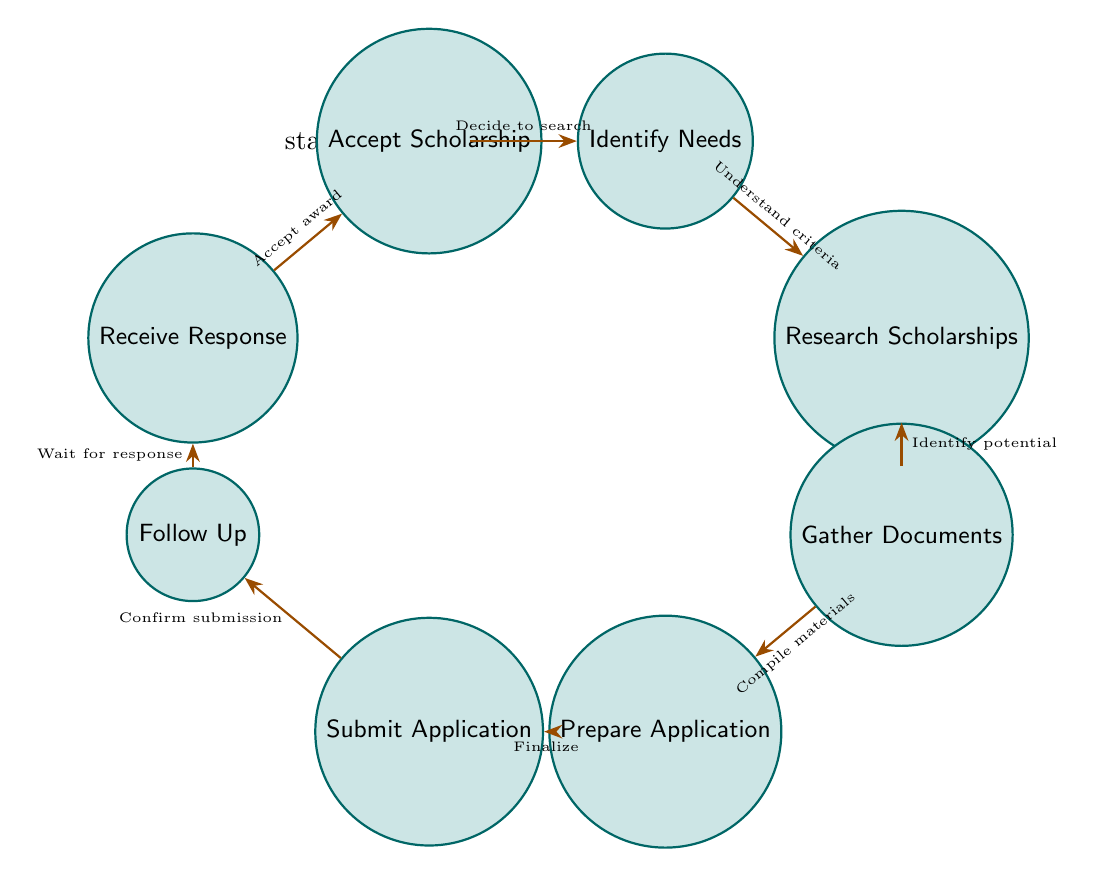What is the initial state of the diagram? The diagram begins at the "Start" state, which is indicated as the initial state.
Answer: Start How many states are there in total? By counting each unique state as represented in the diagram, there are a total of 9 states.
Answer: 9 What is the last state in the process? The last state, as indicated in the flow of the diagram, is "Accept Scholarship."
Answer: Accept Scholarship Which state comes after "Gather Documents"? According to the transitions in the diagram, after "Gather Documents," the next state is "Prepare Application."
Answer: Prepare Application What transition occurs between "Submit Application" and "Follow Up"? The transition from "Submit Application" to "Follow Up" is described as "Confirm submission."
Answer: Confirm submission What is the relationship between "Research Scholarships" and "Gather Documents"? The flow indicates that the transition from "Research Scholarships" to "Gather Documents" is triggered by the action of identifying potential scholarships.
Answer: Identify potential What is the total number of transitions in the diagram? Counting the directed edges connecting each state yields a total of 8 transitions.
Answer: 8 What is required before submitting the application? Before moving to the "Submit Application" state, the required step is to "Prepare Application."
Answer: Prepare Application What does the "Receive Response" state lead to? The "Receive Response" state transitions directly to "Accept Scholarship," indicating acceptance is the subsequent step.
Answer: Accept Scholarship 